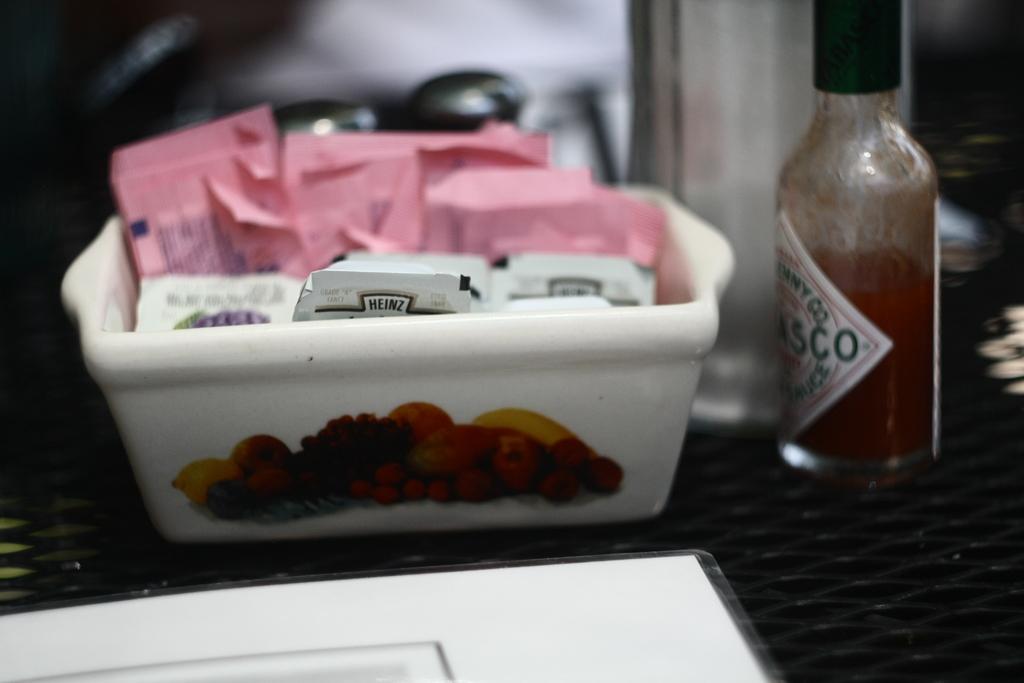What kind of sauce is in the bottle?
Your response must be concise. Tabasco. What brand of product is visible in the dish?
Provide a succinct answer. Heinz. 